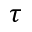<formula> <loc_0><loc_0><loc_500><loc_500>\tau</formula> 